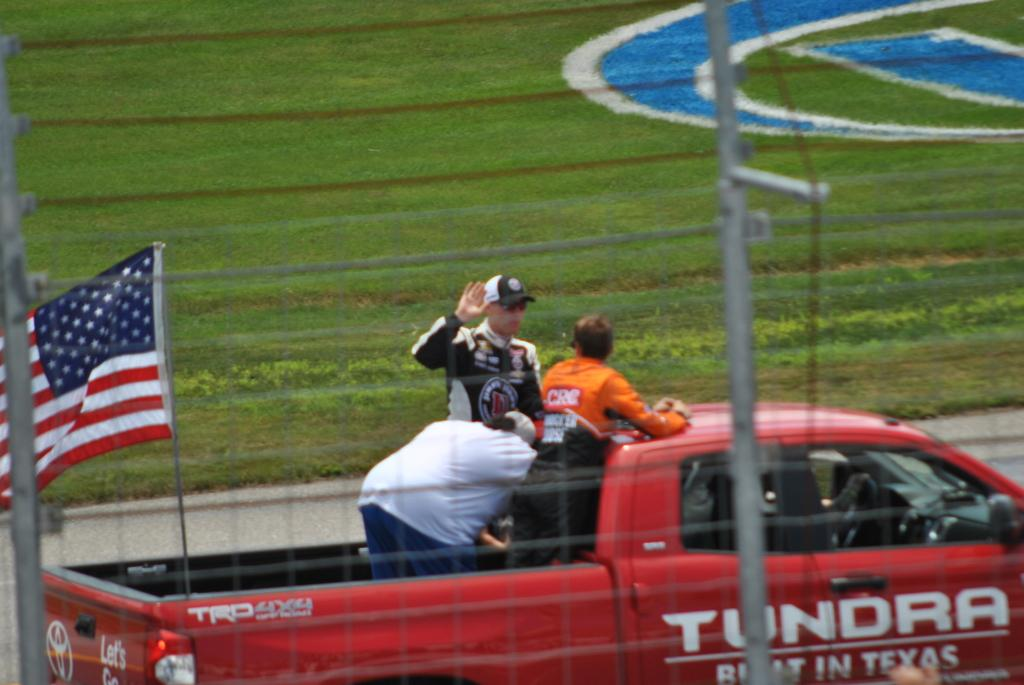What type of structure can be seen in the image? There is fencing in the image. Where is the flag located in the image? The flag is on the left side of the image. What are the people doing in the image? The people are on a vehicle in the image. What type of vegetation is visible in the image? There is grass visible at the back of the image. What type of art can be seen on the ant in the image? There are no ants or art present in the image. How many cows are visible in the image? There are no cows visible in the image. 